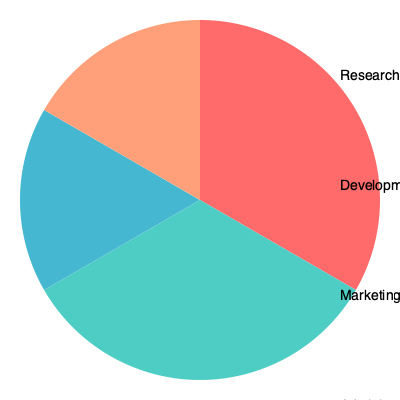In our collaborative initiative's budget allocation, what percentage of the total budget would be left if we removed the two largest expenditure categories? To solve this problem, we need to follow these steps:

1. Identify the two largest expenditure categories:
   - Research: 35%
   - Development: 30%

2. Calculate the sum of these two categories:
   $35\% + 30\% = 65\%$

3. Subtract this sum from the total budget (100%):
   $100\% - 65\% = 35\%$

This 35% represents the remaining budget, which is allocated to Marketing (20%) and Administration (15%).

To verify:
$20\% + 15\% = 35\%$

Therefore, 35% of the total budget would be left after removing the two largest expenditure categories.
Answer: 35% 